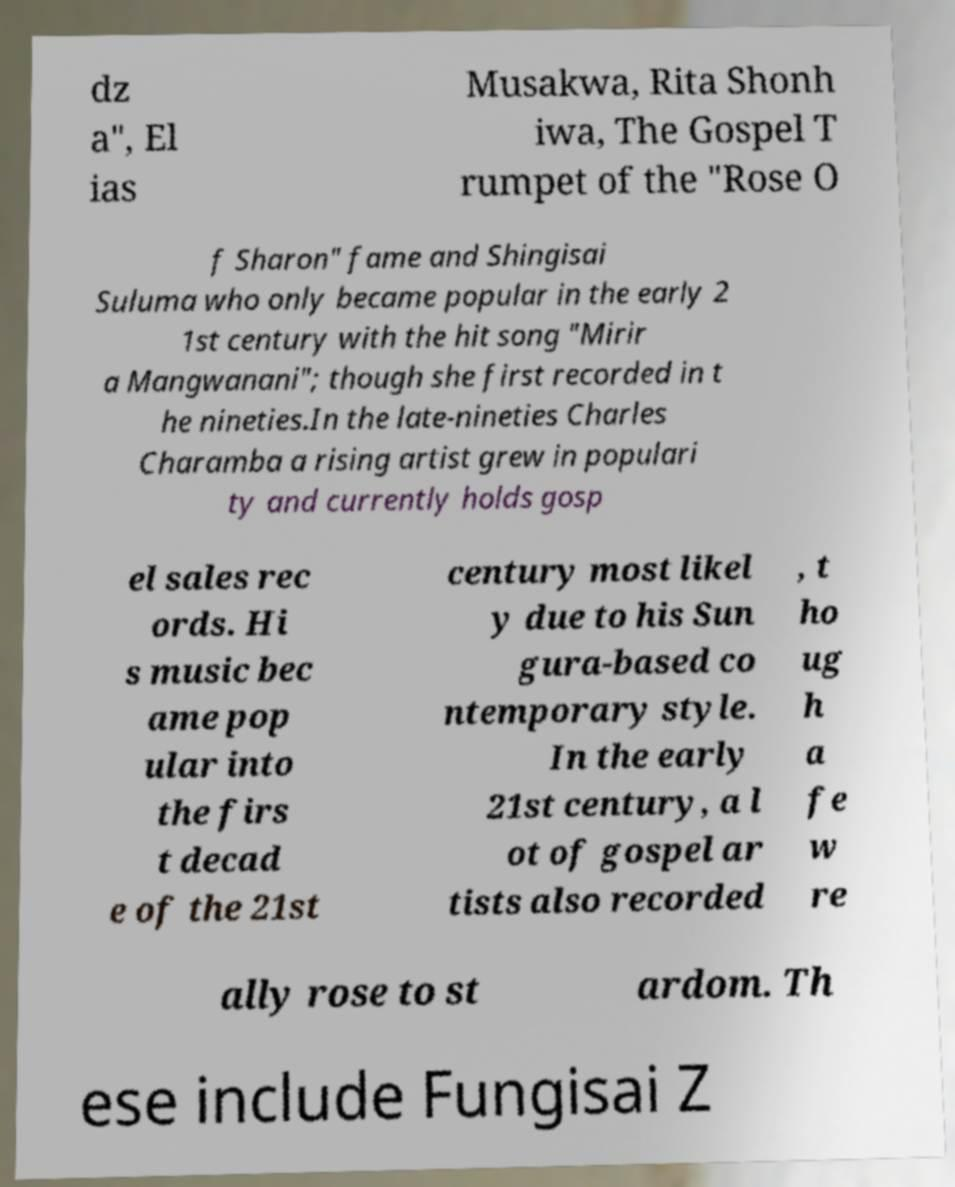For documentation purposes, I need the text within this image transcribed. Could you provide that? dz a", El ias Musakwa, Rita Shonh iwa, The Gospel T rumpet of the "Rose O f Sharon" fame and Shingisai Suluma who only became popular in the early 2 1st century with the hit song "Mirir a Mangwanani"; though she first recorded in t he nineties.In the late-nineties Charles Charamba a rising artist grew in populari ty and currently holds gosp el sales rec ords. Hi s music bec ame pop ular into the firs t decad e of the 21st century most likel y due to his Sun gura-based co ntemporary style. In the early 21st century, a l ot of gospel ar tists also recorded , t ho ug h a fe w re ally rose to st ardom. Th ese include Fungisai Z 